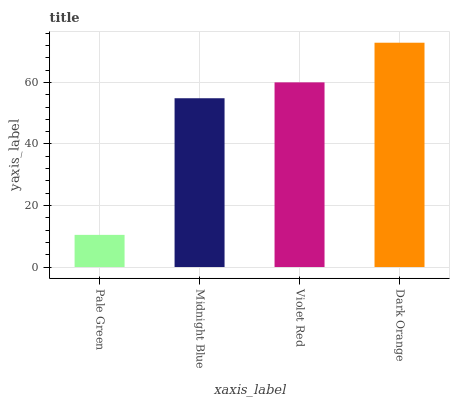Is Pale Green the minimum?
Answer yes or no. Yes. Is Dark Orange the maximum?
Answer yes or no. Yes. Is Midnight Blue the minimum?
Answer yes or no. No. Is Midnight Blue the maximum?
Answer yes or no. No. Is Midnight Blue greater than Pale Green?
Answer yes or no. Yes. Is Pale Green less than Midnight Blue?
Answer yes or no. Yes. Is Pale Green greater than Midnight Blue?
Answer yes or no. No. Is Midnight Blue less than Pale Green?
Answer yes or no. No. Is Violet Red the high median?
Answer yes or no. Yes. Is Midnight Blue the low median?
Answer yes or no. Yes. Is Dark Orange the high median?
Answer yes or no. No. Is Dark Orange the low median?
Answer yes or no. No. 